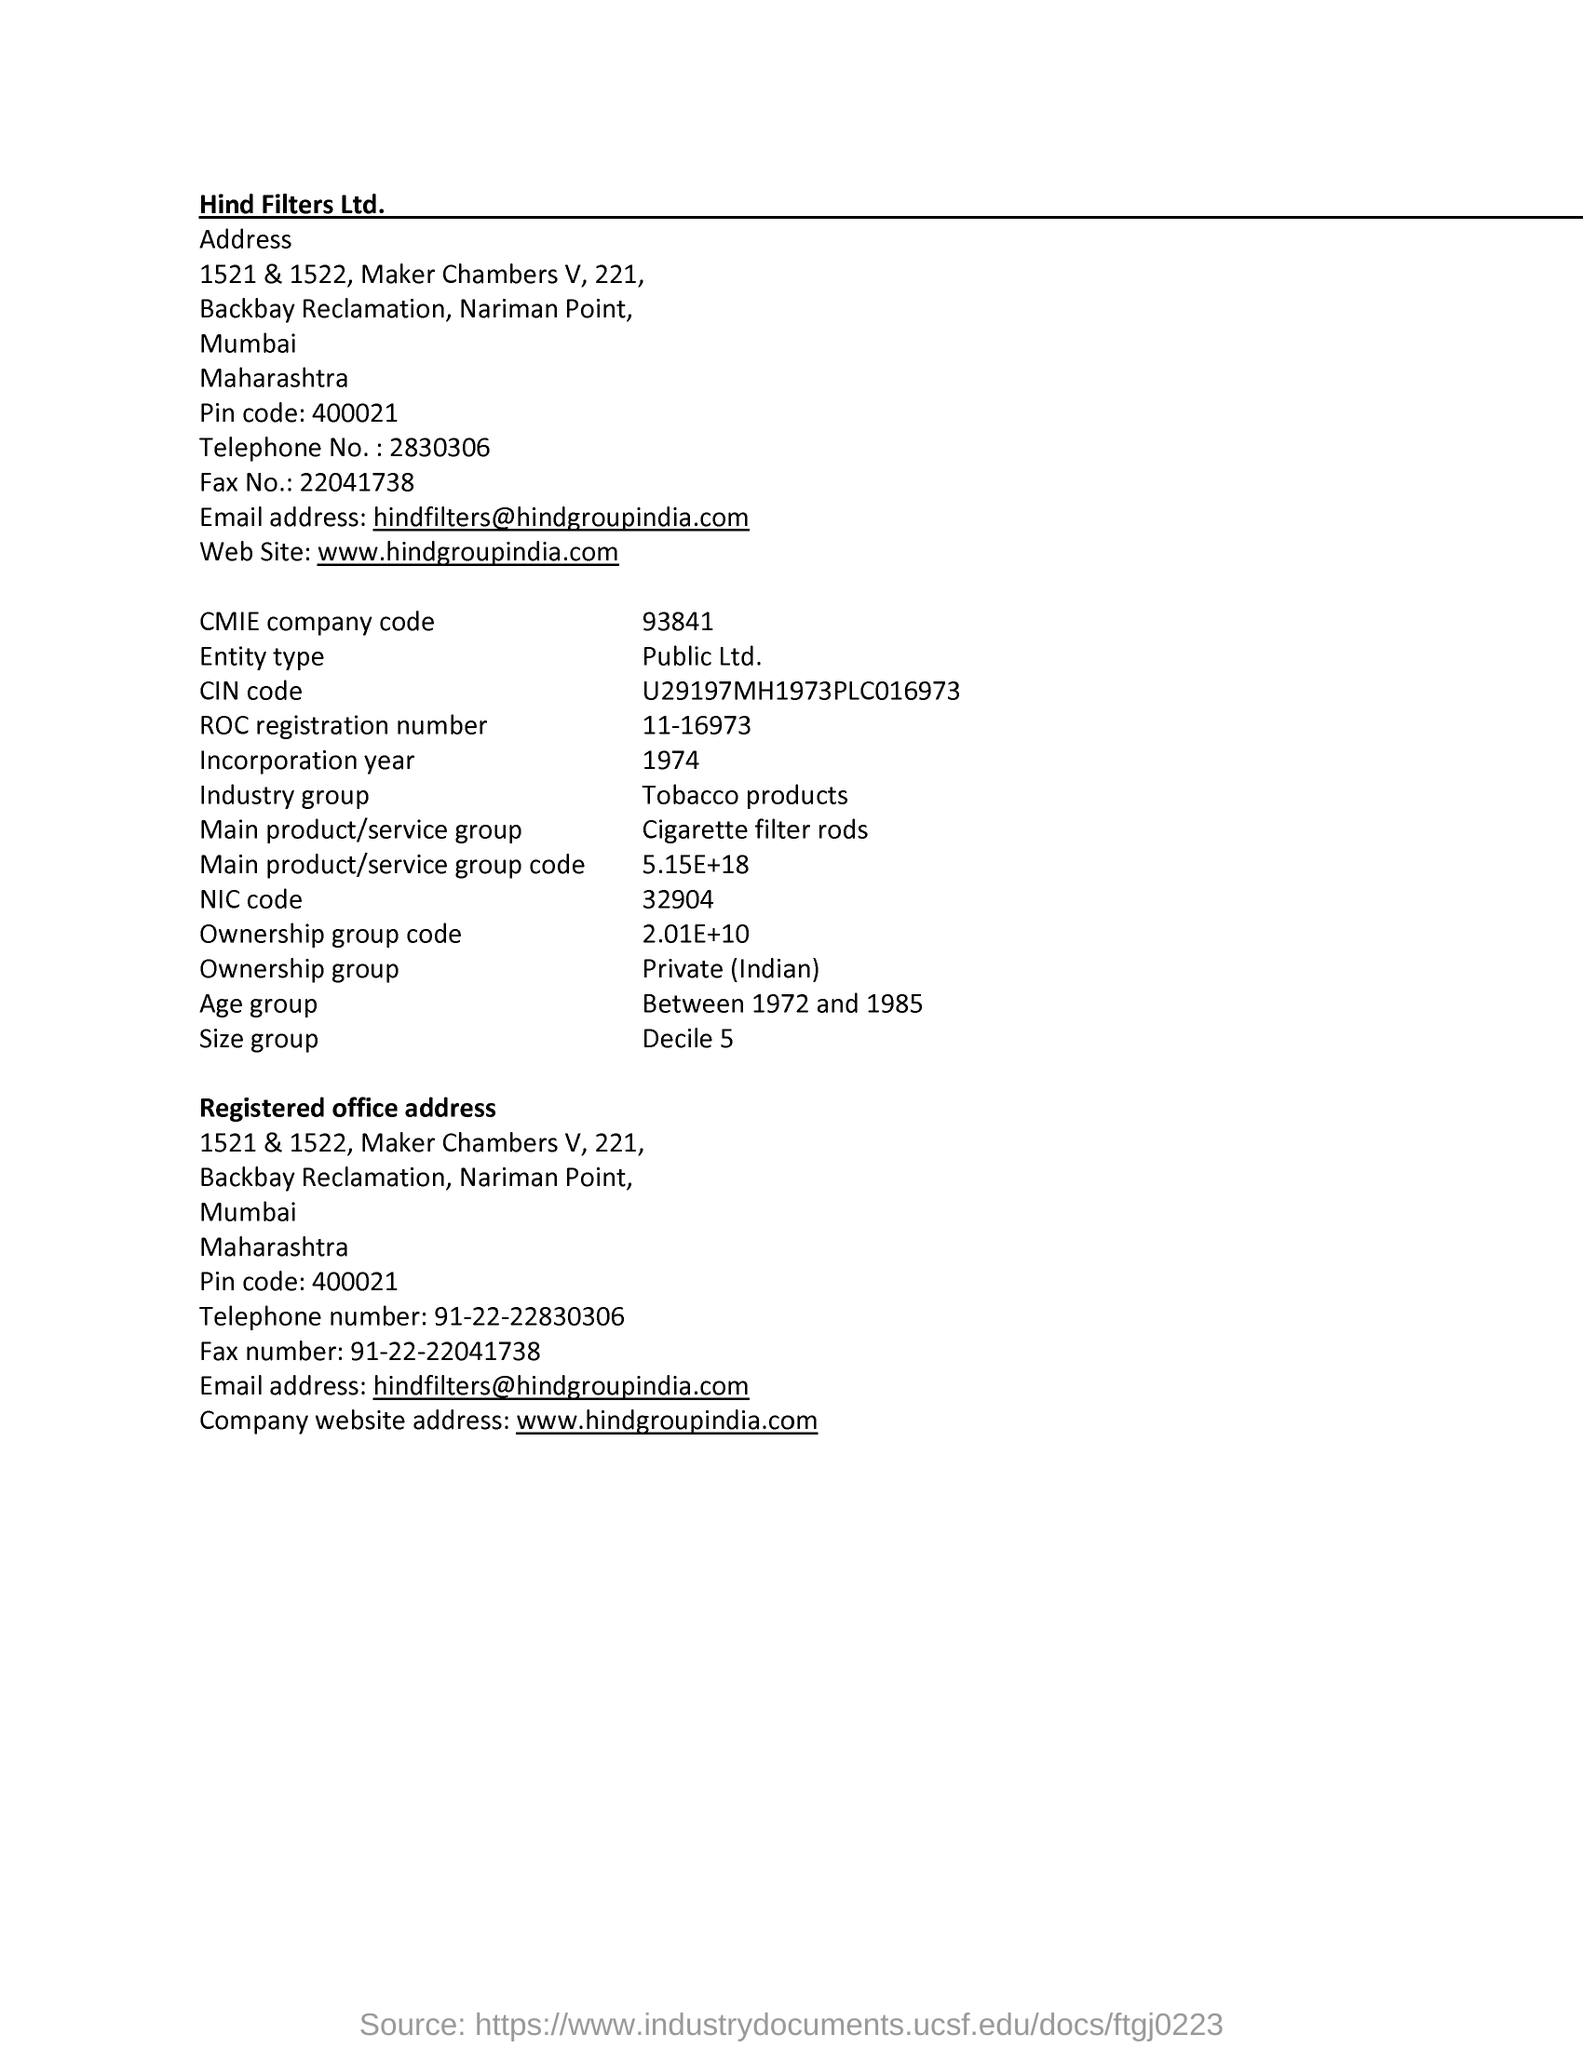Give some essential details in this illustration. The ROC registration number is 11-16973. The email address mentioned is [hindfilters@hindgroupindia.com](mailto:hindfilters@hindgroupindia.com). The fax number mentioned in the address is 22041738.. Maharashtra is mentioned in the address. The website mentioned is [www.hindgroupindia.com](http://www.hindgroupindia.com). 